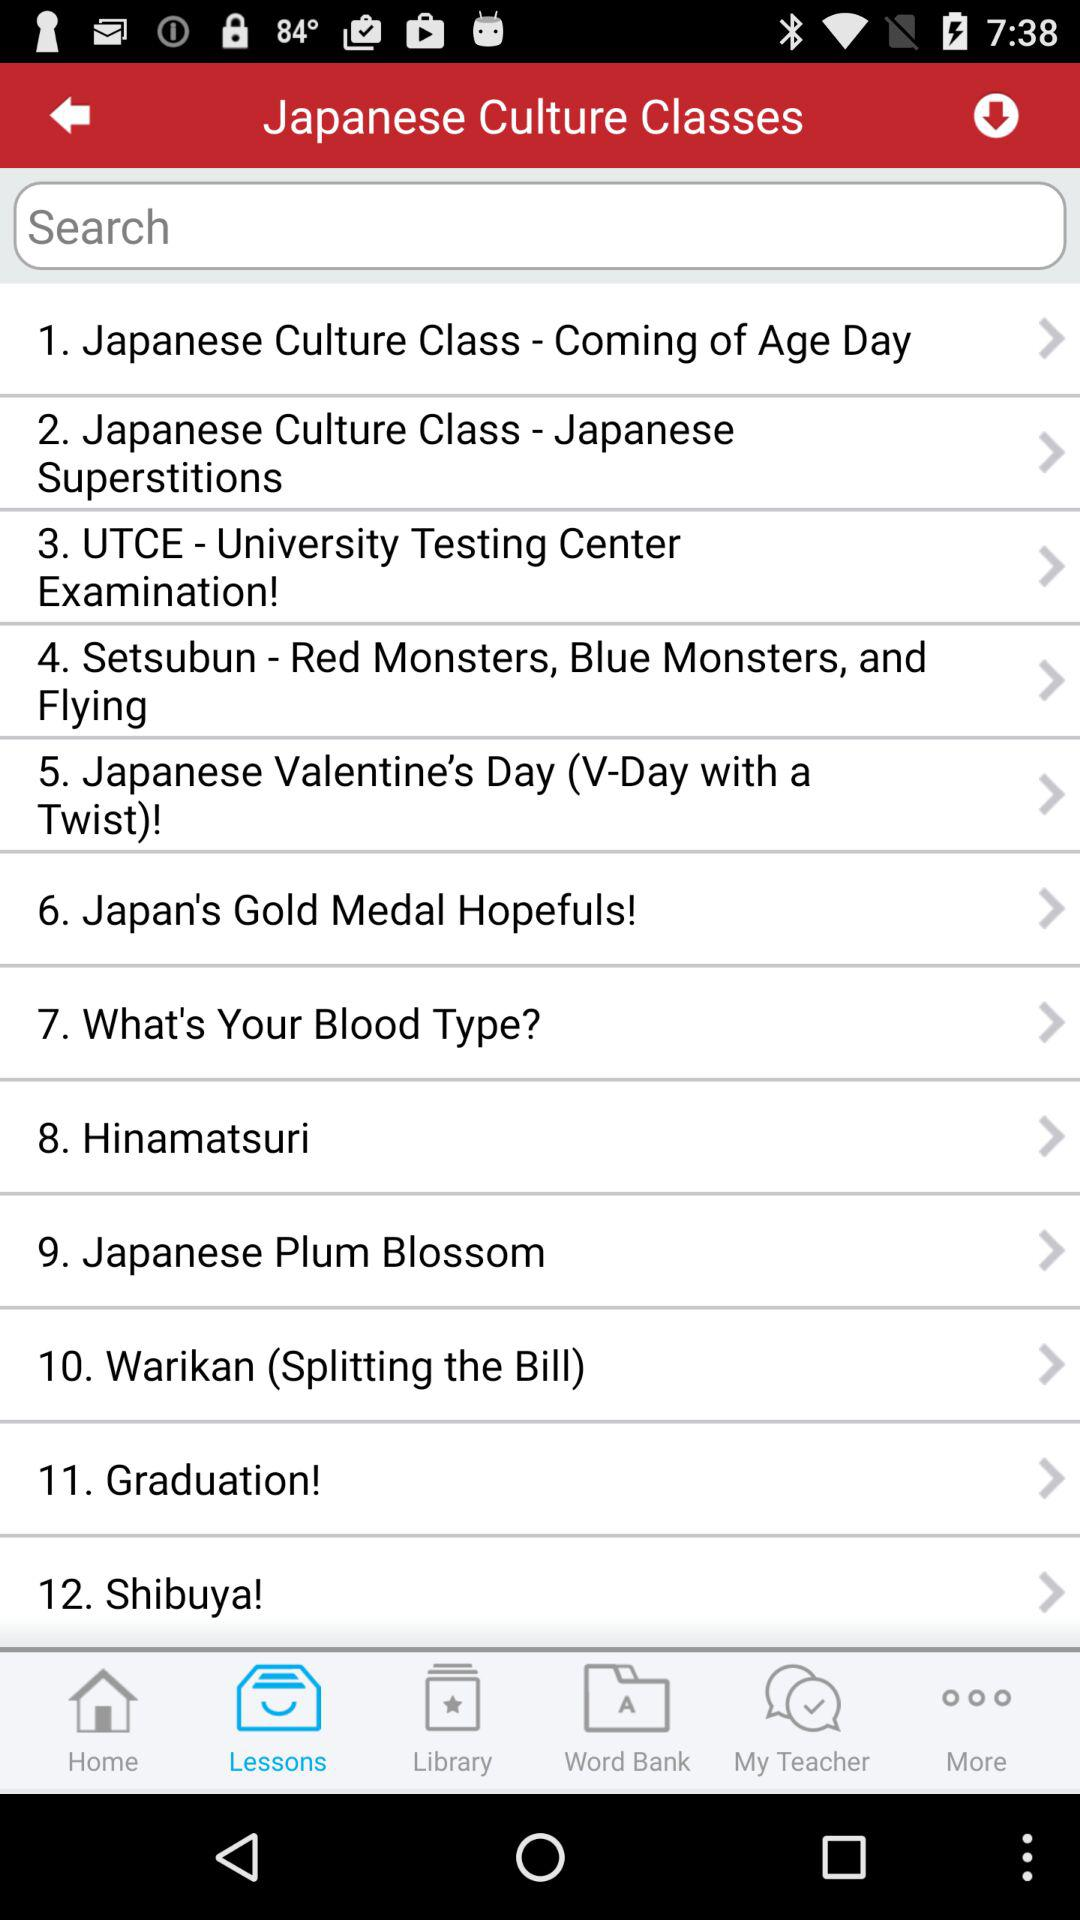Which tab is selected? The selected tab is "Lessons". 